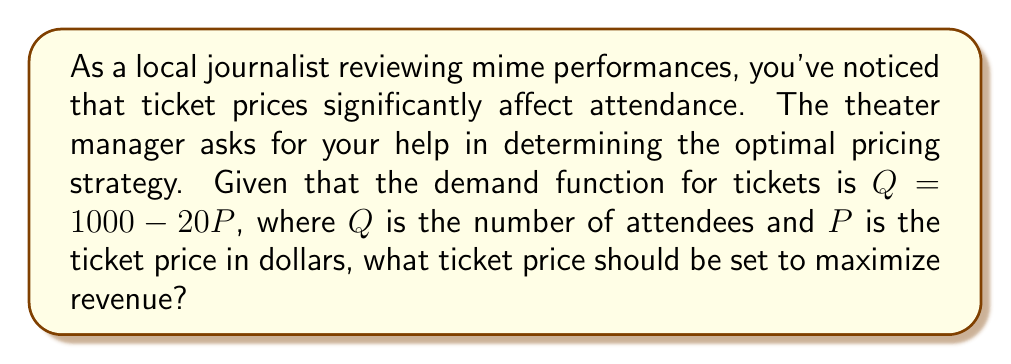Give your solution to this math problem. To solve this problem, we'll follow these steps:

1) The revenue function $R$ is given by price times quantity:
   $R = P \cdot Q$

2) Substitute the demand function into the revenue function:
   $R = P \cdot (1000 - 20P) = 1000P - 20P^2$

3) To find the maximum revenue, we need to find where the derivative of $R$ with respect to $P$ is zero:
   $\frac{dR}{dP} = 1000 - 40P$

4) Set this equal to zero and solve for $P$:
   $1000 - 40P = 0$
   $-40P = -1000$
   $P = 25$

5) To confirm this is a maximum (not a minimum), check the second derivative:
   $\frac{d^2R}{dP^2} = -40$, which is negative, confirming a maximum.

6) Calculate the quantity at this price:
   $Q = 1000 - 20(25) = 500$

Therefore, the optimal ticket price is $25, which would result in 500 attendees.
Answer: The optimal ticket price to maximize revenue is $25. 